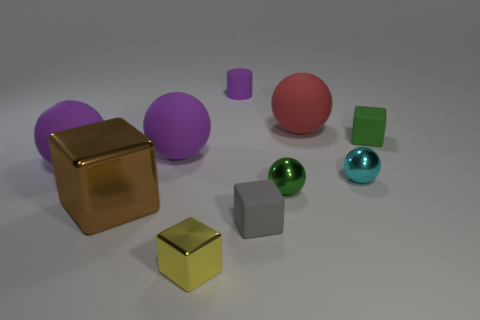There is a small green thing that is behind the tiny green ball; how many tiny rubber blocks are on the left side of it?
Provide a succinct answer. 1. Are any purple matte things visible?
Your response must be concise. Yes. What number of other objects are there of the same color as the big cube?
Offer a very short reply. 0. Is the number of gray cubes less than the number of large things?
Ensure brevity in your answer.  Yes. What is the shape of the purple matte thing that is behind the small matte block that is to the right of the tiny cyan metal thing?
Ensure brevity in your answer.  Cylinder. There is a tiny gray matte block; are there any rubber balls in front of it?
Ensure brevity in your answer.  No. There is another metal block that is the same size as the gray cube; what color is it?
Your answer should be very brief. Yellow. How many tiny green blocks have the same material as the red ball?
Make the answer very short. 1. How many other things are the same size as the brown block?
Provide a succinct answer. 3. Are there any cyan matte spheres of the same size as the red ball?
Keep it short and to the point. No. 